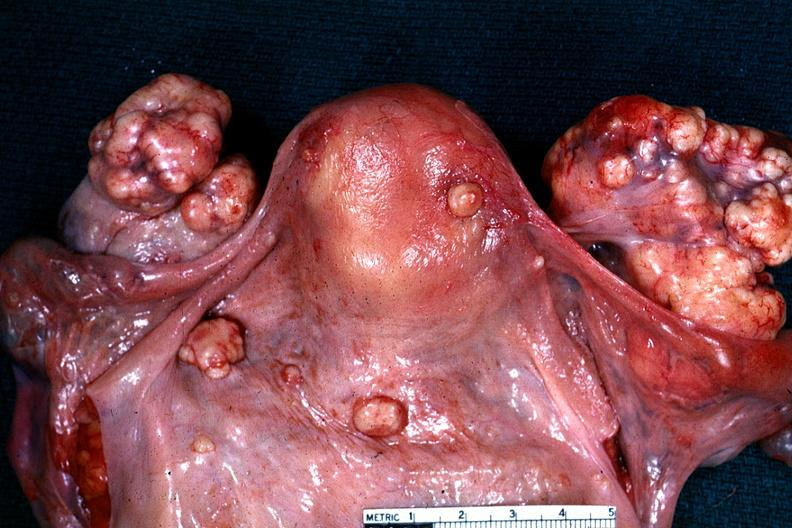what is present?
Answer the question using a single word or phrase. Female reproductive 